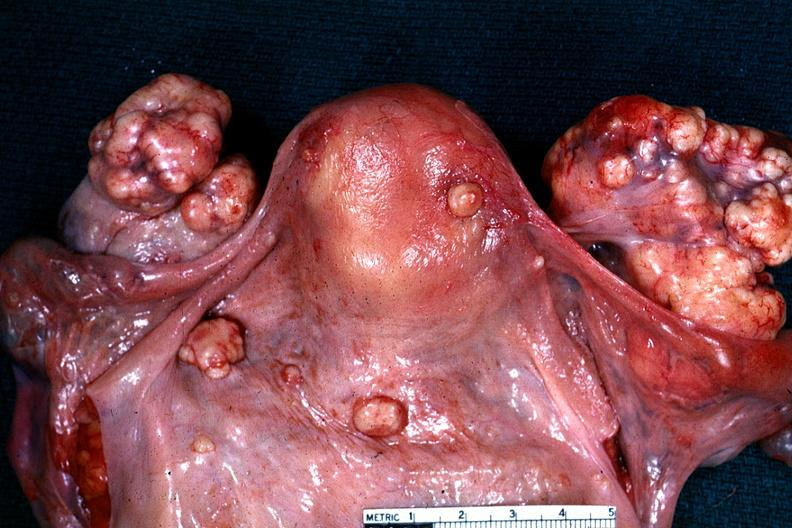what is present?
Answer the question using a single word or phrase. Female reproductive 